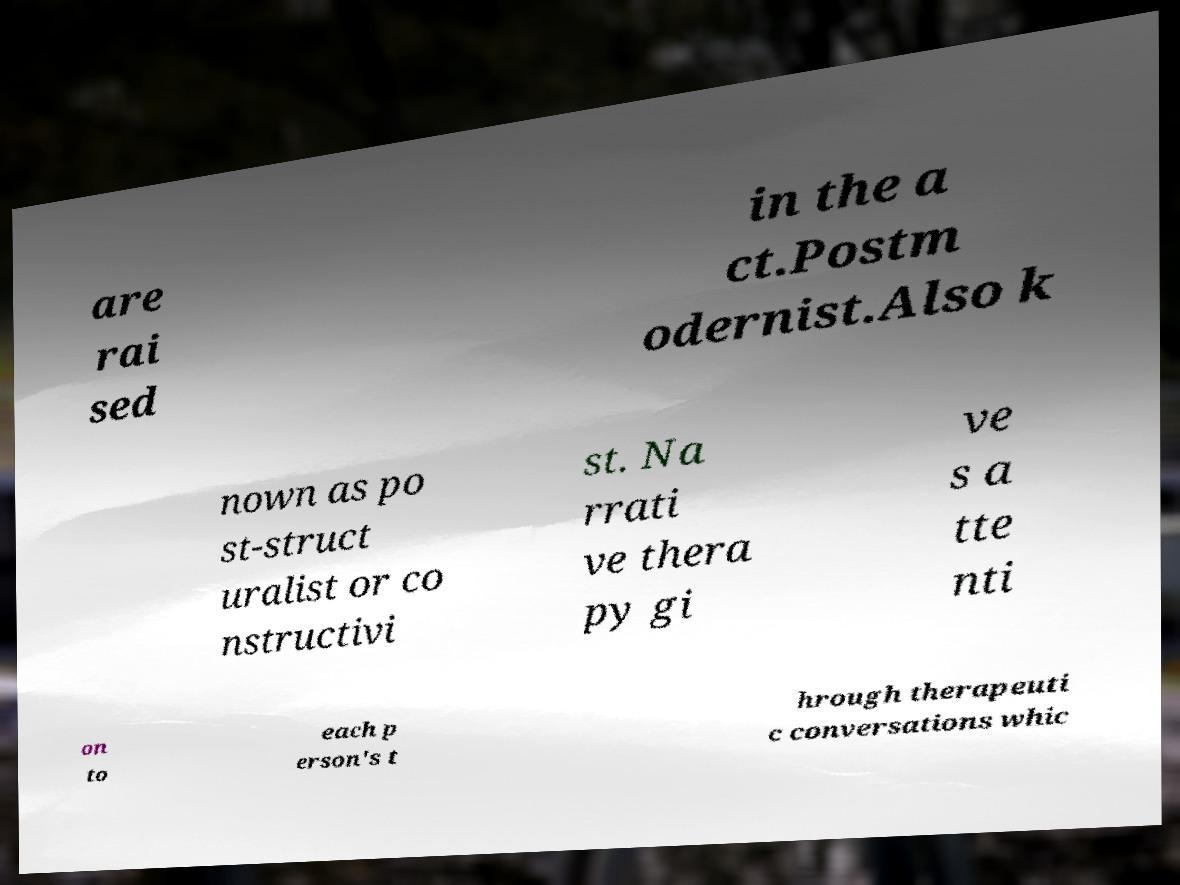There's text embedded in this image that I need extracted. Can you transcribe it verbatim? are rai sed in the a ct.Postm odernist.Also k nown as po st-struct uralist or co nstructivi st. Na rrati ve thera py gi ve s a tte nti on to each p erson's t hrough therapeuti c conversations whic 